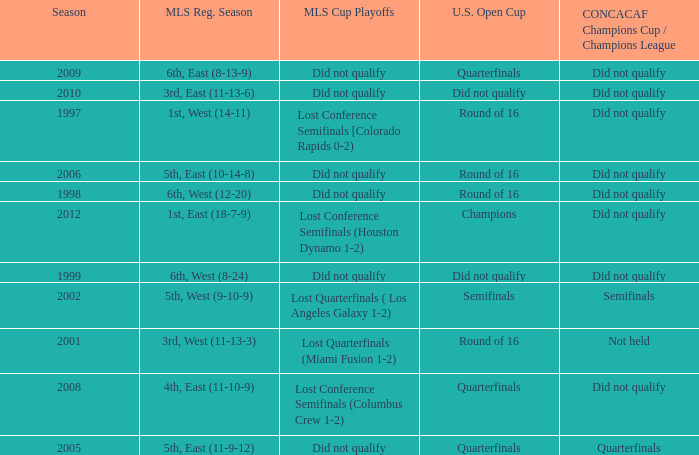When was the first season? 1997.0. 